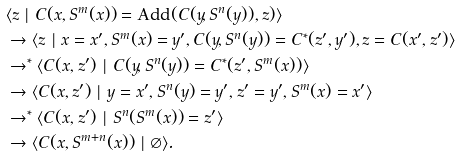<formula> <loc_0><loc_0><loc_500><loc_500>& \langle z \ | \ C ( x , S ^ { m } ( x ) ) = \text {Add} ( C ( y , S ^ { n } ( y ) ) , z ) \rangle \\ & \rightarrow \langle z \ | \ x = x ^ { \prime } , S ^ { m } ( x ) = y ^ { \prime } , C ( y , S ^ { n } ( y ) ) = C ^ { * } ( z ^ { \prime } , y ^ { \prime } ) , z = C ( x ^ { \prime } , z ^ { \prime } ) \rangle \\ & \rightarrow ^ { * } \langle C ( x , z ^ { \prime } ) \ | \ C ( y , S ^ { n } ( y ) ) = C ^ { * } ( z ^ { \prime } , S ^ { m } ( x ) ) \rangle \\ & \rightarrow \langle C ( x , z ^ { \prime } ) \ | \ y = x ^ { \prime } , S ^ { n } ( y ) = y ^ { \prime } , z ^ { \prime } = y ^ { \prime } , S ^ { m } ( x ) = x ^ { \prime } \rangle \\ & \rightarrow ^ { * } \langle C ( x , z ^ { \prime } ) \ | \ S ^ { n } ( S ^ { m } ( x ) ) = z ^ { \prime } \rangle \\ & \rightarrow \langle C ( x , S ^ { m + n } ( x ) ) \ | \ \varnothing \rangle .</formula> 